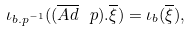<formula> <loc_0><loc_0><loc_500><loc_500>\iota _ { b . p ^ { - 1 } } ( ( \overline { A d } \ p ) . \overline { \xi } ) = \iota _ { b } ( \overline { \xi } ) ,</formula> 